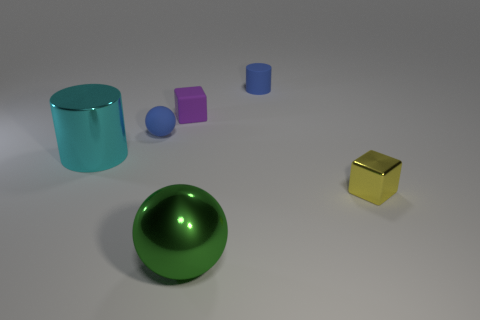Is there a cyan cylinder that has the same size as the green metallic sphere?
Offer a very short reply. Yes. What number of cyan metal things are the same shape as the small yellow metallic thing?
Offer a very short reply. 0. Is the number of small blue rubber things that are in front of the large green shiny thing the same as the number of tiny blue things that are in front of the purple cube?
Ensure brevity in your answer.  No. Is there a cyan metal ball?
Your answer should be very brief. No. There is a cylinder in front of the small matte object behind the small block behind the tiny yellow metal object; what size is it?
Make the answer very short. Large. What is the shape of the green thing that is the same size as the cyan metal thing?
Provide a short and direct response. Sphere. How many objects are either blocks behind the yellow shiny thing or brown shiny spheres?
Keep it short and to the point. 1. Are there any tiny cylinders in front of the object that is to the right of the blue thing that is behind the small purple rubber block?
Provide a succinct answer. No. What number of green rubber things are there?
Provide a short and direct response. 0. How many objects are rubber cylinders that are left of the small yellow metallic cube or shiny objects to the left of the tiny matte ball?
Your answer should be compact. 2. 